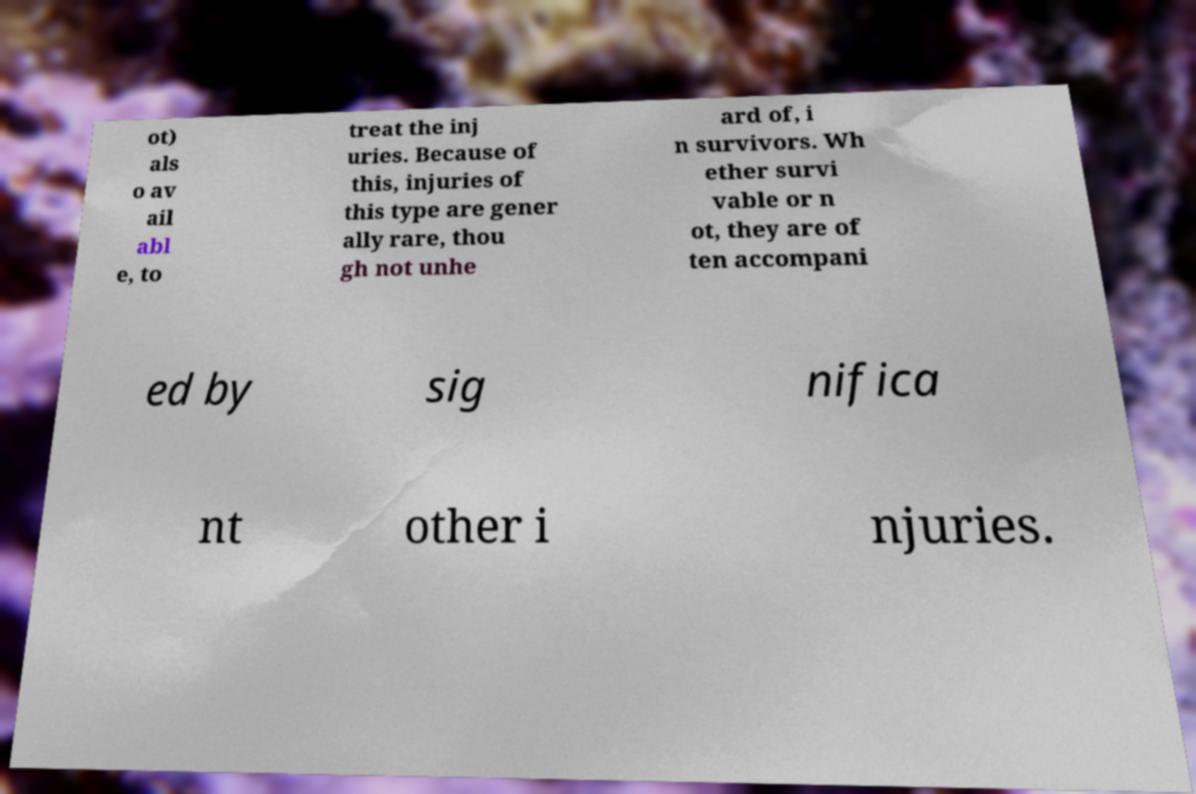I need the written content from this picture converted into text. Can you do that? ot) als o av ail abl e, to treat the inj uries. Because of this, injuries of this type are gener ally rare, thou gh not unhe ard of, i n survivors. Wh ether survi vable or n ot, they are of ten accompani ed by sig nifica nt other i njuries. 